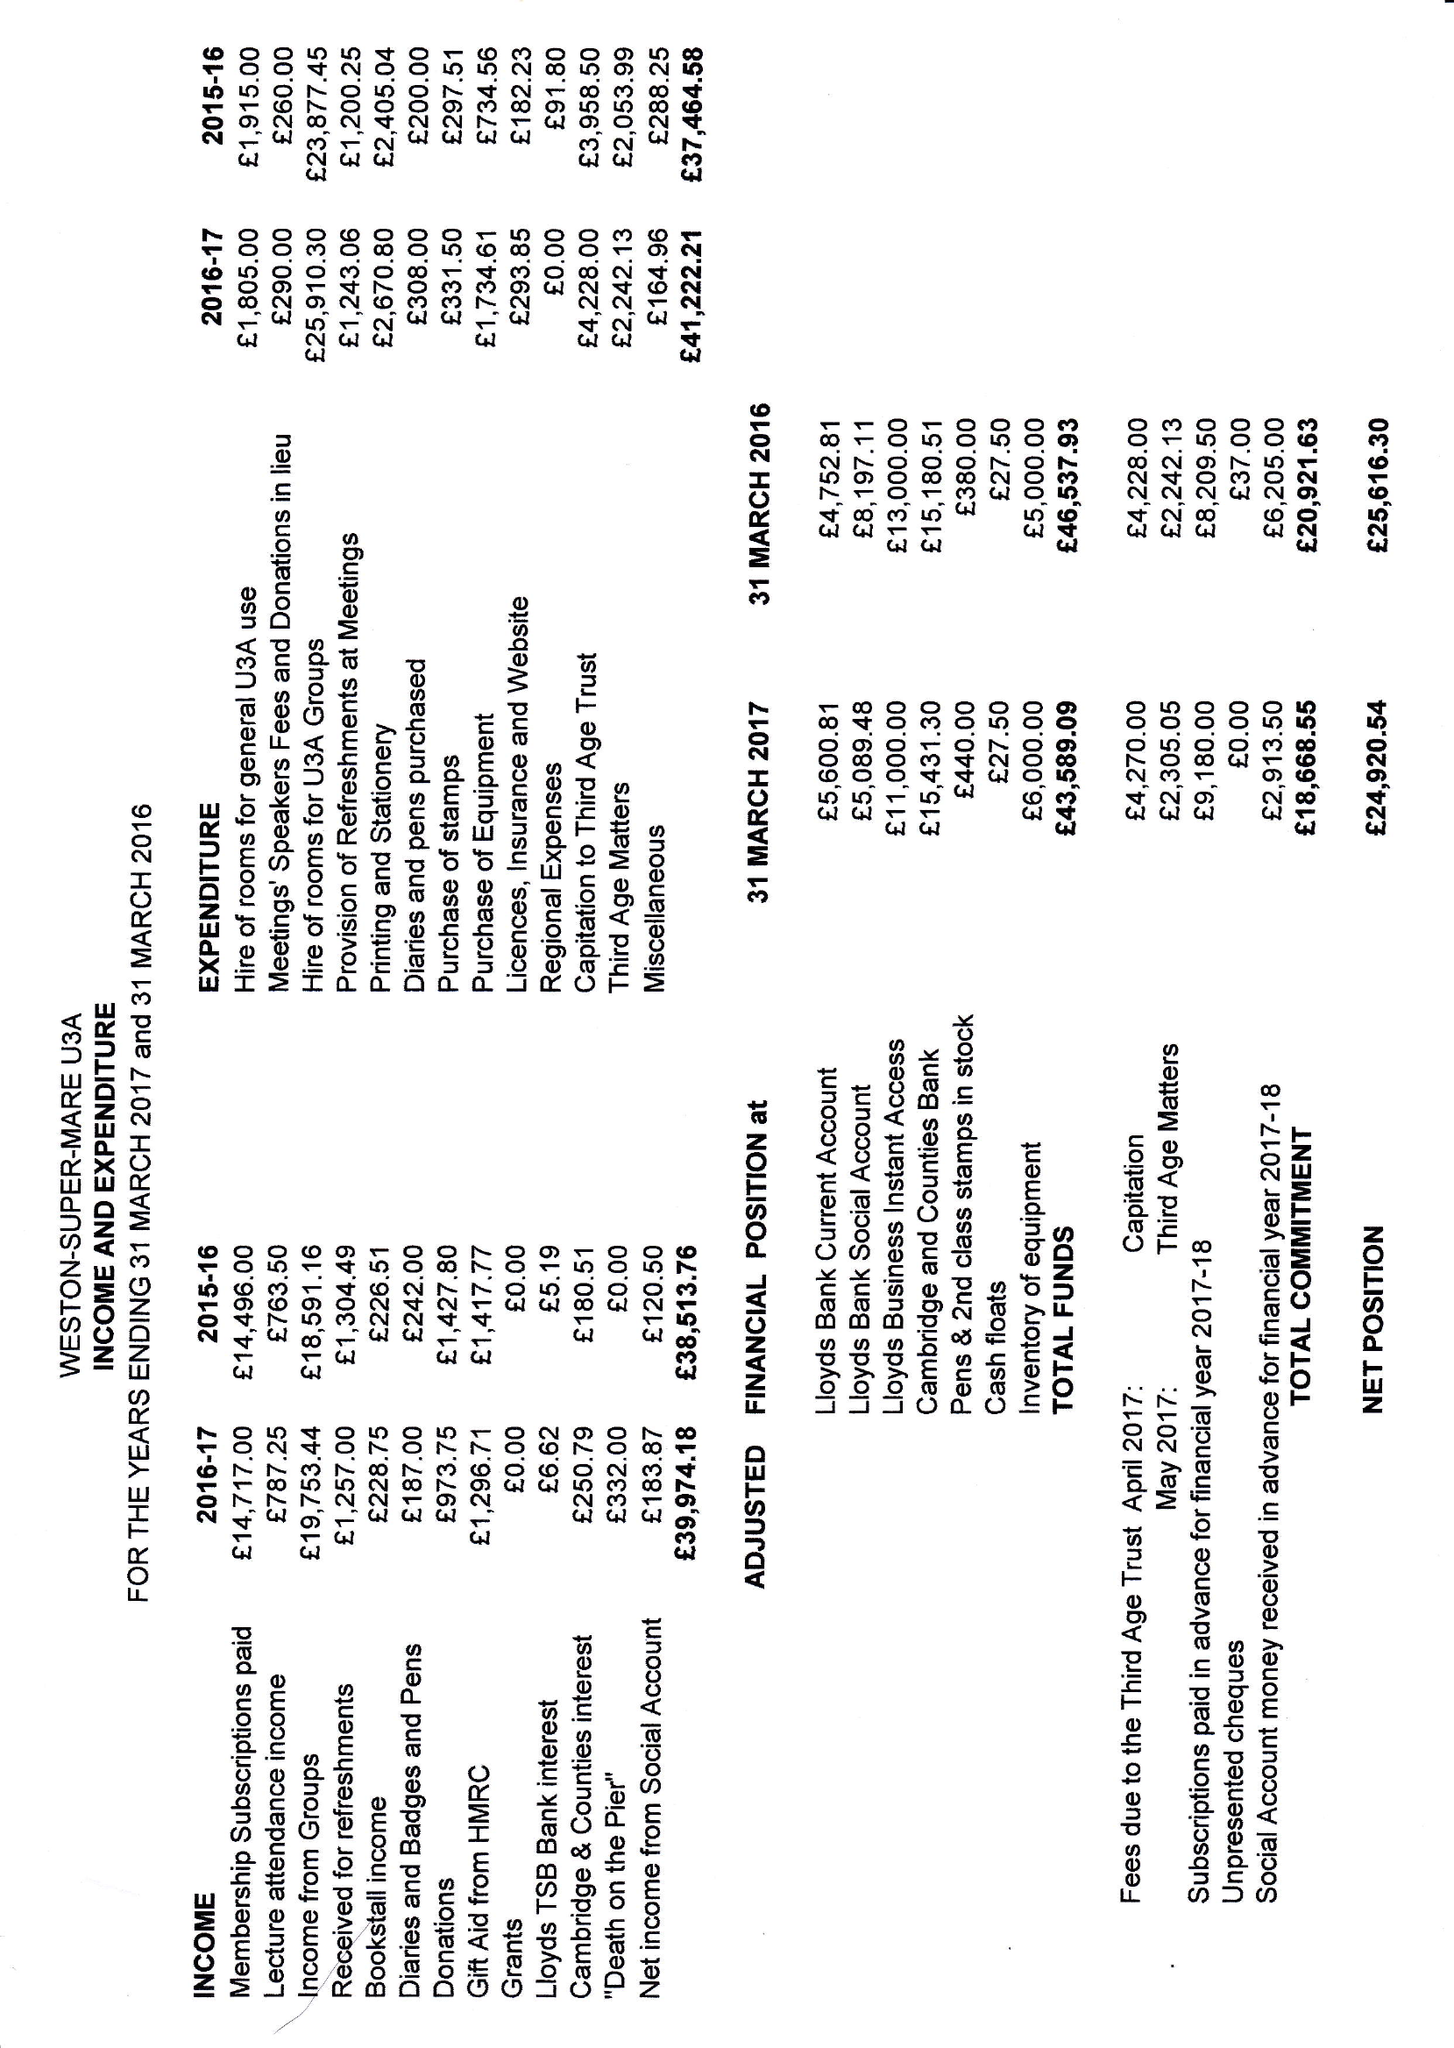What is the value for the address__postcode?
Answer the question using a single word or phrase. BS22 9AQ 